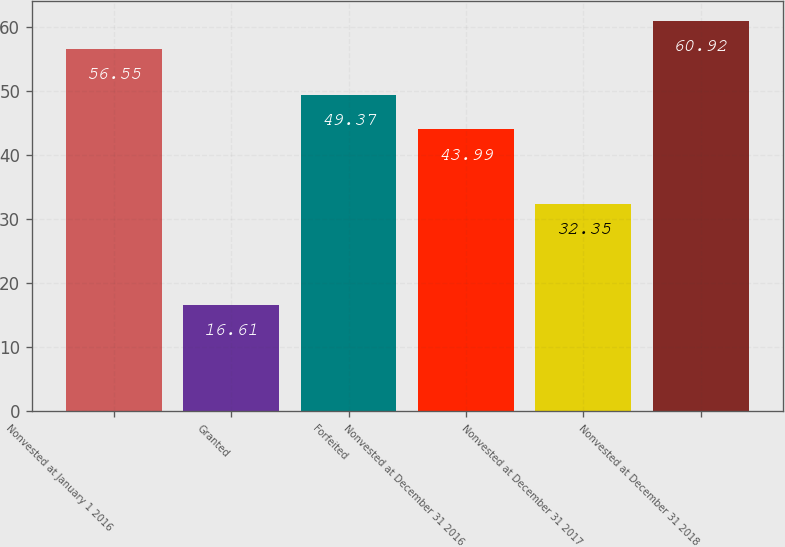Convert chart. <chart><loc_0><loc_0><loc_500><loc_500><bar_chart><fcel>Nonvested at January 1 2016<fcel>Granted<fcel>Forfeited<fcel>Nonvested at December 31 2016<fcel>Nonvested at December 31 2017<fcel>Nonvested at December 31 2018<nl><fcel>56.55<fcel>16.61<fcel>49.37<fcel>43.99<fcel>32.35<fcel>60.92<nl></chart> 